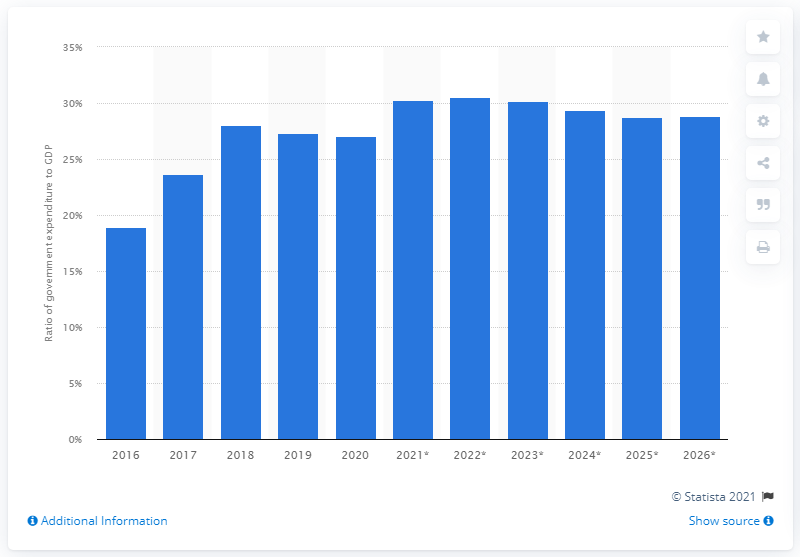Mention a couple of crucial points in this snapshot. In 2020, approximately 27.03% of Nepal's Gross Domestic Product (GDP) was allocated to government expenditure. 